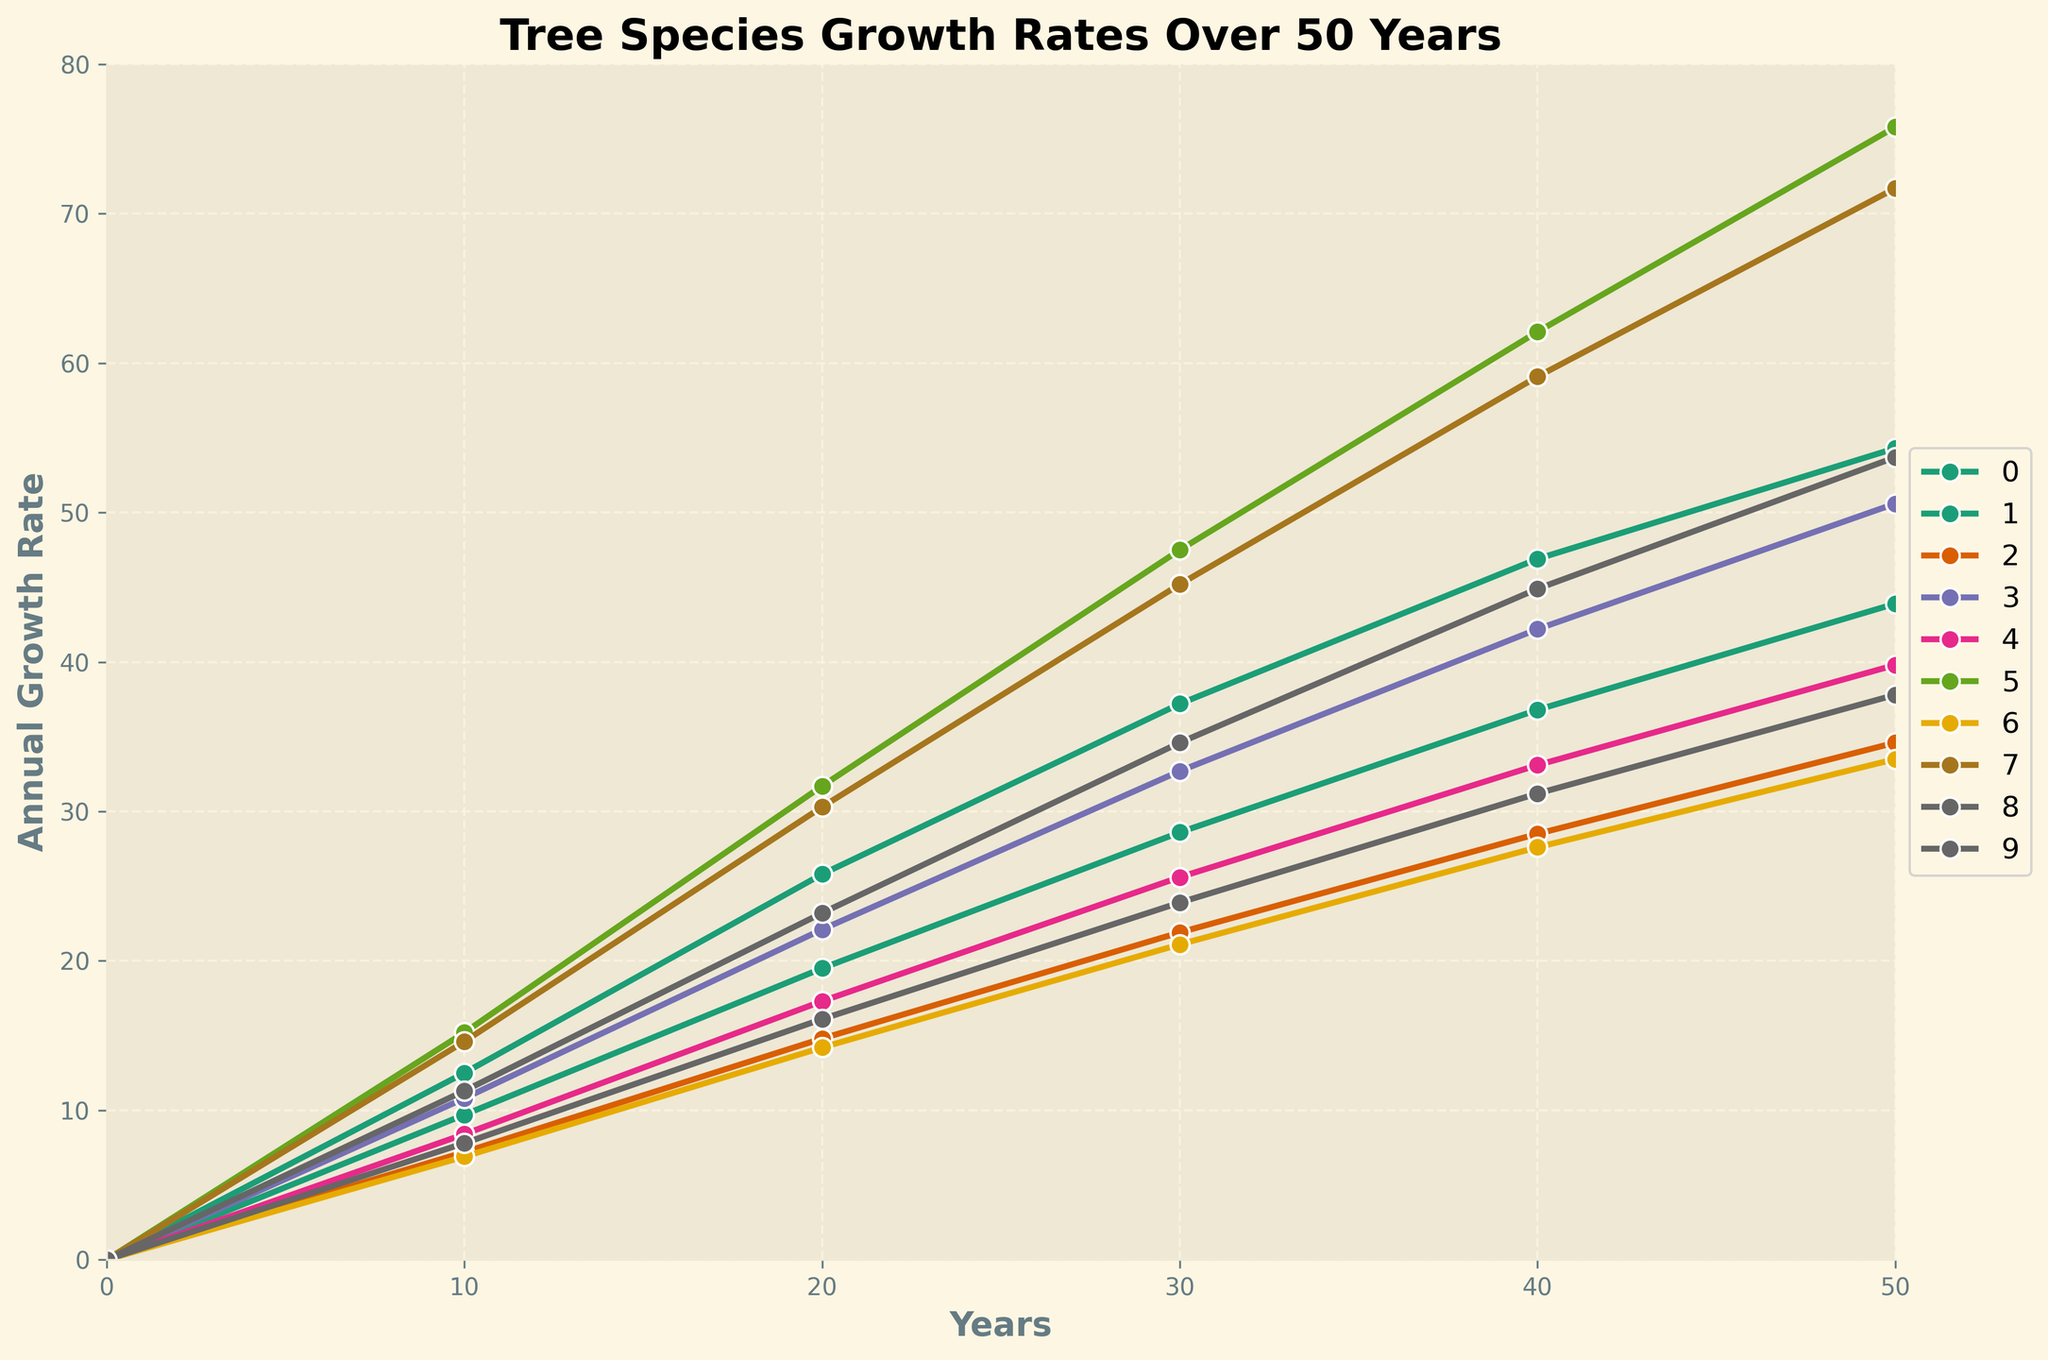How many tree species reach an annual growth rate of at least 50 units after 50 years? From the plot, locate the lines corresponding to each tree species. At the 50-year mark, check which species have growth rates of 50 or above.
Answer: 5 Which tree species exhibits the highest annual growth rate at the 20-year mark? Observe the plot at the 20-year mark and identify which species has the highest data point.
Answer: Giant Sequoia How does the growth rate of the Coast Redwood compare to the Loblolly Pine at the 50-year mark? Look at the heights of the data points for both the Coast Redwood and Loblolly Pine at the 50-year mark, then compare them.
Answer: Coast Redwood > Loblolly Pine What is the average annual growth rate of the Sugar Maple and Yellow Birch after 50 years? Sum the growth rates of Sugar Maple and Yellow Birch at the 50-year mark and divide by 2. Calculations: (34.6 + 37.8) / 2
Answer: 36.2 By how much does the growth rate of European Beech increase from 10 to 40 years? Subtract the growth rate of European Beech at 10 years from that at 40 years. Calculation: 33.1 - 8.4
Answer: 24.7 Which tree species has the slowest growth rate at the 30-year mark? Find the lowest data point among the tree species at the 30 years mark.
Answer: White Spruce What is the growth difference between Ponderosa Pine and Douglas Fir at the 50-year mark? Subtract the growth rate of Douglas Fir at 50 years from that of Ponderosa Pine. Calculation: 50.6 - 54.3
Answer: -3.7 Identify the tree species that average a growth rate greater than 40 units over 50 years. Calculate the average for each species over the years and identify those above 40 units.
Answer: Giant Sequoia, Coast Redwood What is the total growth rate of all species at 50 years combined? Sum the growth rates of all species at the 50-year mark. Calculation: 54.3 + 43.9 + 34.6 + 50.6 + 39.8 + 75.8 + 33.5 + 71.7 + 37.8 + 53.7
Answer: 495.7 Is the growth rate trend of any tree species nonlinear, showing rapid acceleration or deceleration? Scan the entire plot to spot lines that significantly change slope, indicating nonlinearity.
Answer: Yes, Giant Sequoia 